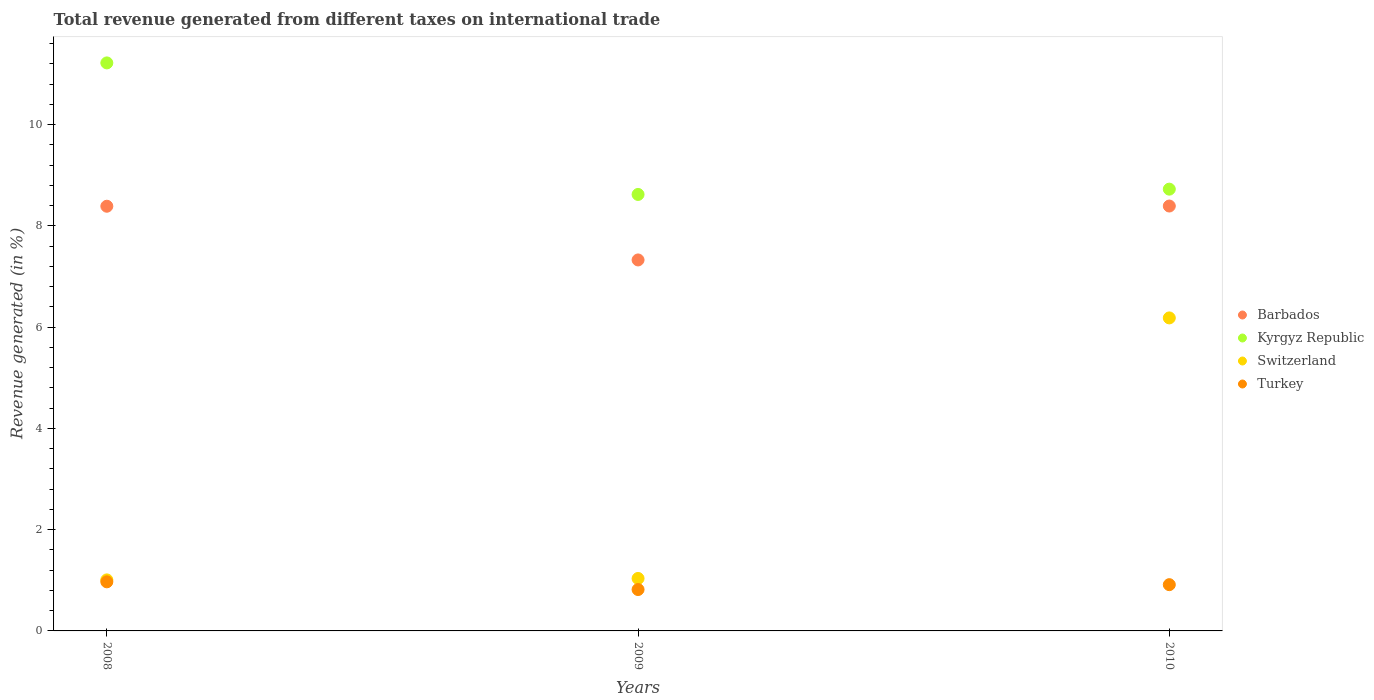What is the total revenue generated in Kyrgyz Republic in 2010?
Make the answer very short. 8.73. Across all years, what is the maximum total revenue generated in Kyrgyz Republic?
Ensure brevity in your answer.  11.22. Across all years, what is the minimum total revenue generated in Kyrgyz Republic?
Offer a very short reply. 8.62. In which year was the total revenue generated in Barbados minimum?
Provide a succinct answer. 2009. What is the total total revenue generated in Switzerland in the graph?
Provide a succinct answer. 8.23. What is the difference between the total revenue generated in Turkey in 2008 and that in 2010?
Your answer should be very brief. 0.06. What is the difference between the total revenue generated in Switzerland in 2008 and the total revenue generated in Turkey in 2010?
Your answer should be very brief. 0.09. What is the average total revenue generated in Barbados per year?
Your answer should be very brief. 8.04. In the year 2009, what is the difference between the total revenue generated in Kyrgyz Republic and total revenue generated in Switzerland?
Offer a very short reply. 7.59. What is the ratio of the total revenue generated in Barbados in 2009 to that in 2010?
Give a very brief answer. 0.87. Is the total revenue generated in Kyrgyz Republic in 2008 less than that in 2009?
Your answer should be compact. No. Is the difference between the total revenue generated in Kyrgyz Republic in 2009 and 2010 greater than the difference between the total revenue generated in Switzerland in 2009 and 2010?
Give a very brief answer. Yes. What is the difference between the highest and the second highest total revenue generated in Kyrgyz Republic?
Offer a very short reply. 2.49. What is the difference between the highest and the lowest total revenue generated in Turkey?
Offer a very short reply. 0.15. Is the sum of the total revenue generated in Turkey in 2008 and 2009 greater than the maximum total revenue generated in Switzerland across all years?
Your response must be concise. No. How many dotlines are there?
Give a very brief answer. 4. What is the difference between two consecutive major ticks on the Y-axis?
Your response must be concise. 2. Are the values on the major ticks of Y-axis written in scientific E-notation?
Your answer should be compact. No. Does the graph contain any zero values?
Provide a short and direct response. No. Does the graph contain grids?
Make the answer very short. No. How many legend labels are there?
Ensure brevity in your answer.  4. How are the legend labels stacked?
Your answer should be compact. Vertical. What is the title of the graph?
Offer a terse response. Total revenue generated from different taxes on international trade. Does "Mauritania" appear as one of the legend labels in the graph?
Ensure brevity in your answer.  No. What is the label or title of the X-axis?
Make the answer very short. Years. What is the label or title of the Y-axis?
Ensure brevity in your answer.  Revenue generated (in %). What is the Revenue generated (in %) of Barbados in 2008?
Offer a very short reply. 8.39. What is the Revenue generated (in %) of Kyrgyz Republic in 2008?
Keep it short and to the point. 11.22. What is the Revenue generated (in %) of Switzerland in 2008?
Give a very brief answer. 1.01. What is the Revenue generated (in %) of Turkey in 2008?
Give a very brief answer. 0.97. What is the Revenue generated (in %) of Barbados in 2009?
Make the answer very short. 7.33. What is the Revenue generated (in %) of Kyrgyz Republic in 2009?
Make the answer very short. 8.62. What is the Revenue generated (in %) in Switzerland in 2009?
Your answer should be very brief. 1.04. What is the Revenue generated (in %) of Turkey in 2009?
Your response must be concise. 0.82. What is the Revenue generated (in %) in Barbados in 2010?
Ensure brevity in your answer.  8.39. What is the Revenue generated (in %) of Kyrgyz Republic in 2010?
Offer a terse response. 8.73. What is the Revenue generated (in %) of Switzerland in 2010?
Your answer should be very brief. 6.18. What is the Revenue generated (in %) of Turkey in 2010?
Your response must be concise. 0.91. Across all years, what is the maximum Revenue generated (in %) of Barbados?
Offer a terse response. 8.39. Across all years, what is the maximum Revenue generated (in %) of Kyrgyz Republic?
Provide a succinct answer. 11.22. Across all years, what is the maximum Revenue generated (in %) in Switzerland?
Provide a succinct answer. 6.18. Across all years, what is the maximum Revenue generated (in %) in Turkey?
Offer a very short reply. 0.97. Across all years, what is the minimum Revenue generated (in %) in Barbados?
Offer a very short reply. 7.33. Across all years, what is the minimum Revenue generated (in %) of Kyrgyz Republic?
Offer a terse response. 8.62. Across all years, what is the minimum Revenue generated (in %) of Switzerland?
Offer a terse response. 1.01. Across all years, what is the minimum Revenue generated (in %) in Turkey?
Your answer should be compact. 0.82. What is the total Revenue generated (in %) of Barbados in the graph?
Keep it short and to the point. 24.11. What is the total Revenue generated (in %) of Kyrgyz Republic in the graph?
Your answer should be compact. 28.57. What is the total Revenue generated (in %) of Switzerland in the graph?
Offer a terse response. 8.23. What is the total Revenue generated (in %) in Turkey in the graph?
Make the answer very short. 2.7. What is the difference between the Revenue generated (in %) of Barbados in 2008 and that in 2009?
Give a very brief answer. 1.06. What is the difference between the Revenue generated (in %) in Kyrgyz Republic in 2008 and that in 2009?
Give a very brief answer. 2.6. What is the difference between the Revenue generated (in %) of Switzerland in 2008 and that in 2009?
Offer a terse response. -0.03. What is the difference between the Revenue generated (in %) in Turkey in 2008 and that in 2009?
Your response must be concise. 0.15. What is the difference between the Revenue generated (in %) of Barbados in 2008 and that in 2010?
Your answer should be compact. -0. What is the difference between the Revenue generated (in %) of Kyrgyz Republic in 2008 and that in 2010?
Keep it short and to the point. 2.49. What is the difference between the Revenue generated (in %) in Switzerland in 2008 and that in 2010?
Your answer should be compact. -5.17. What is the difference between the Revenue generated (in %) of Turkey in 2008 and that in 2010?
Offer a very short reply. 0.06. What is the difference between the Revenue generated (in %) in Barbados in 2009 and that in 2010?
Offer a very short reply. -1.06. What is the difference between the Revenue generated (in %) of Kyrgyz Republic in 2009 and that in 2010?
Keep it short and to the point. -0.1. What is the difference between the Revenue generated (in %) of Switzerland in 2009 and that in 2010?
Ensure brevity in your answer.  -5.15. What is the difference between the Revenue generated (in %) in Turkey in 2009 and that in 2010?
Make the answer very short. -0.1. What is the difference between the Revenue generated (in %) of Barbados in 2008 and the Revenue generated (in %) of Kyrgyz Republic in 2009?
Offer a very short reply. -0.23. What is the difference between the Revenue generated (in %) in Barbados in 2008 and the Revenue generated (in %) in Switzerland in 2009?
Your response must be concise. 7.35. What is the difference between the Revenue generated (in %) of Barbados in 2008 and the Revenue generated (in %) of Turkey in 2009?
Keep it short and to the point. 7.57. What is the difference between the Revenue generated (in %) of Kyrgyz Republic in 2008 and the Revenue generated (in %) of Switzerland in 2009?
Give a very brief answer. 10.18. What is the difference between the Revenue generated (in %) of Kyrgyz Republic in 2008 and the Revenue generated (in %) of Turkey in 2009?
Keep it short and to the point. 10.4. What is the difference between the Revenue generated (in %) of Switzerland in 2008 and the Revenue generated (in %) of Turkey in 2009?
Provide a succinct answer. 0.19. What is the difference between the Revenue generated (in %) in Barbados in 2008 and the Revenue generated (in %) in Kyrgyz Republic in 2010?
Offer a very short reply. -0.34. What is the difference between the Revenue generated (in %) in Barbados in 2008 and the Revenue generated (in %) in Switzerland in 2010?
Your response must be concise. 2.21. What is the difference between the Revenue generated (in %) of Barbados in 2008 and the Revenue generated (in %) of Turkey in 2010?
Provide a short and direct response. 7.48. What is the difference between the Revenue generated (in %) in Kyrgyz Republic in 2008 and the Revenue generated (in %) in Switzerland in 2010?
Offer a terse response. 5.04. What is the difference between the Revenue generated (in %) of Kyrgyz Republic in 2008 and the Revenue generated (in %) of Turkey in 2010?
Provide a succinct answer. 10.31. What is the difference between the Revenue generated (in %) in Switzerland in 2008 and the Revenue generated (in %) in Turkey in 2010?
Offer a very short reply. 0.09. What is the difference between the Revenue generated (in %) of Barbados in 2009 and the Revenue generated (in %) of Kyrgyz Republic in 2010?
Your answer should be very brief. -1.4. What is the difference between the Revenue generated (in %) in Barbados in 2009 and the Revenue generated (in %) in Switzerland in 2010?
Provide a short and direct response. 1.15. What is the difference between the Revenue generated (in %) of Barbados in 2009 and the Revenue generated (in %) of Turkey in 2010?
Keep it short and to the point. 6.41. What is the difference between the Revenue generated (in %) in Kyrgyz Republic in 2009 and the Revenue generated (in %) in Switzerland in 2010?
Keep it short and to the point. 2.44. What is the difference between the Revenue generated (in %) in Kyrgyz Republic in 2009 and the Revenue generated (in %) in Turkey in 2010?
Your answer should be very brief. 7.71. What is the difference between the Revenue generated (in %) of Switzerland in 2009 and the Revenue generated (in %) of Turkey in 2010?
Provide a succinct answer. 0.12. What is the average Revenue generated (in %) of Barbados per year?
Offer a terse response. 8.04. What is the average Revenue generated (in %) of Kyrgyz Republic per year?
Offer a very short reply. 9.52. What is the average Revenue generated (in %) in Switzerland per year?
Keep it short and to the point. 2.74. What is the average Revenue generated (in %) in Turkey per year?
Make the answer very short. 0.9. In the year 2008, what is the difference between the Revenue generated (in %) of Barbados and Revenue generated (in %) of Kyrgyz Republic?
Your response must be concise. -2.83. In the year 2008, what is the difference between the Revenue generated (in %) of Barbados and Revenue generated (in %) of Switzerland?
Your answer should be compact. 7.38. In the year 2008, what is the difference between the Revenue generated (in %) of Barbados and Revenue generated (in %) of Turkey?
Keep it short and to the point. 7.42. In the year 2008, what is the difference between the Revenue generated (in %) of Kyrgyz Republic and Revenue generated (in %) of Switzerland?
Ensure brevity in your answer.  10.21. In the year 2008, what is the difference between the Revenue generated (in %) in Kyrgyz Republic and Revenue generated (in %) in Turkey?
Your answer should be very brief. 10.25. In the year 2008, what is the difference between the Revenue generated (in %) of Switzerland and Revenue generated (in %) of Turkey?
Ensure brevity in your answer.  0.04. In the year 2009, what is the difference between the Revenue generated (in %) of Barbados and Revenue generated (in %) of Kyrgyz Republic?
Your answer should be very brief. -1.29. In the year 2009, what is the difference between the Revenue generated (in %) in Barbados and Revenue generated (in %) in Switzerland?
Your answer should be very brief. 6.29. In the year 2009, what is the difference between the Revenue generated (in %) of Barbados and Revenue generated (in %) of Turkey?
Provide a short and direct response. 6.51. In the year 2009, what is the difference between the Revenue generated (in %) of Kyrgyz Republic and Revenue generated (in %) of Switzerland?
Your response must be concise. 7.59. In the year 2009, what is the difference between the Revenue generated (in %) of Kyrgyz Republic and Revenue generated (in %) of Turkey?
Your answer should be very brief. 7.8. In the year 2009, what is the difference between the Revenue generated (in %) of Switzerland and Revenue generated (in %) of Turkey?
Offer a very short reply. 0.22. In the year 2010, what is the difference between the Revenue generated (in %) in Barbados and Revenue generated (in %) in Kyrgyz Republic?
Your answer should be compact. -0.33. In the year 2010, what is the difference between the Revenue generated (in %) of Barbados and Revenue generated (in %) of Switzerland?
Your response must be concise. 2.21. In the year 2010, what is the difference between the Revenue generated (in %) in Barbados and Revenue generated (in %) in Turkey?
Give a very brief answer. 7.48. In the year 2010, what is the difference between the Revenue generated (in %) in Kyrgyz Republic and Revenue generated (in %) in Switzerland?
Offer a very short reply. 2.54. In the year 2010, what is the difference between the Revenue generated (in %) of Kyrgyz Republic and Revenue generated (in %) of Turkey?
Provide a succinct answer. 7.81. In the year 2010, what is the difference between the Revenue generated (in %) in Switzerland and Revenue generated (in %) in Turkey?
Keep it short and to the point. 5.27. What is the ratio of the Revenue generated (in %) of Barbados in 2008 to that in 2009?
Offer a very short reply. 1.14. What is the ratio of the Revenue generated (in %) of Kyrgyz Republic in 2008 to that in 2009?
Provide a short and direct response. 1.3. What is the ratio of the Revenue generated (in %) in Switzerland in 2008 to that in 2009?
Provide a short and direct response. 0.97. What is the ratio of the Revenue generated (in %) of Turkey in 2008 to that in 2009?
Give a very brief answer. 1.19. What is the ratio of the Revenue generated (in %) of Barbados in 2008 to that in 2010?
Your response must be concise. 1. What is the ratio of the Revenue generated (in %) of Kyrgyz Republic in 2008 to that in 2010?
Your answer should be very brief. 1.29. What is the ratio of the Revenue generated (in %) in Switzerland in 2008 to that in 2010?
Offer a very short reply. 0.16. What is the ratio of the Revenue generated (in %) in Turkey in 2008 to that in 2010?
Make the answer very short. 1.06. What is the ratio of the Revenue generated (in %) in Barbados in 2009 to that in 2010?
Ensure brevity in your answer.  0.87. What is the ratio of the Revenue generated (in %) of Switzerland in 2009 to that in 2010?
Offer a very short reply. 0.17. What is the ratio of the Revenue generated (in %) of Turkey in 2009 to that in 2010?
Your response must be concise. 0.89. What is the difference between the highest and the second highest Revenue generated (in %) in Barbados?
Ensure brevity in your answer.  0. What is the difference between the highest and the second highest Revenue generated (in %) of Kyrgyz Republic?
Your answer should be compact. 2.49. What is the difference between the highest and the second highest Revenue generated (in %) of Switzerland?
Offer a terse response. 5.15. What is the difference between the highest and the second highest Revenue generated (in %) in Turkey?
Keep it short and to the point. 0.06. What is the difference between the highest and the lowest Revenue generated (in %) of Barbados?
Offer a terse response. 1.06. What is the difference between the highest and the lowest Revenue generated (in %) in Kyrgyz Republic?
Give a very brief answer. 2.6. What is the difference between the highest and the lowest Revenue generated (in %) in Switzerland?
Keep it short and to the point. 5.17. What is the difference between the highest and the lowest Revenue generated (in %) in Turkey?
Give a very brief answer. 0.15. 